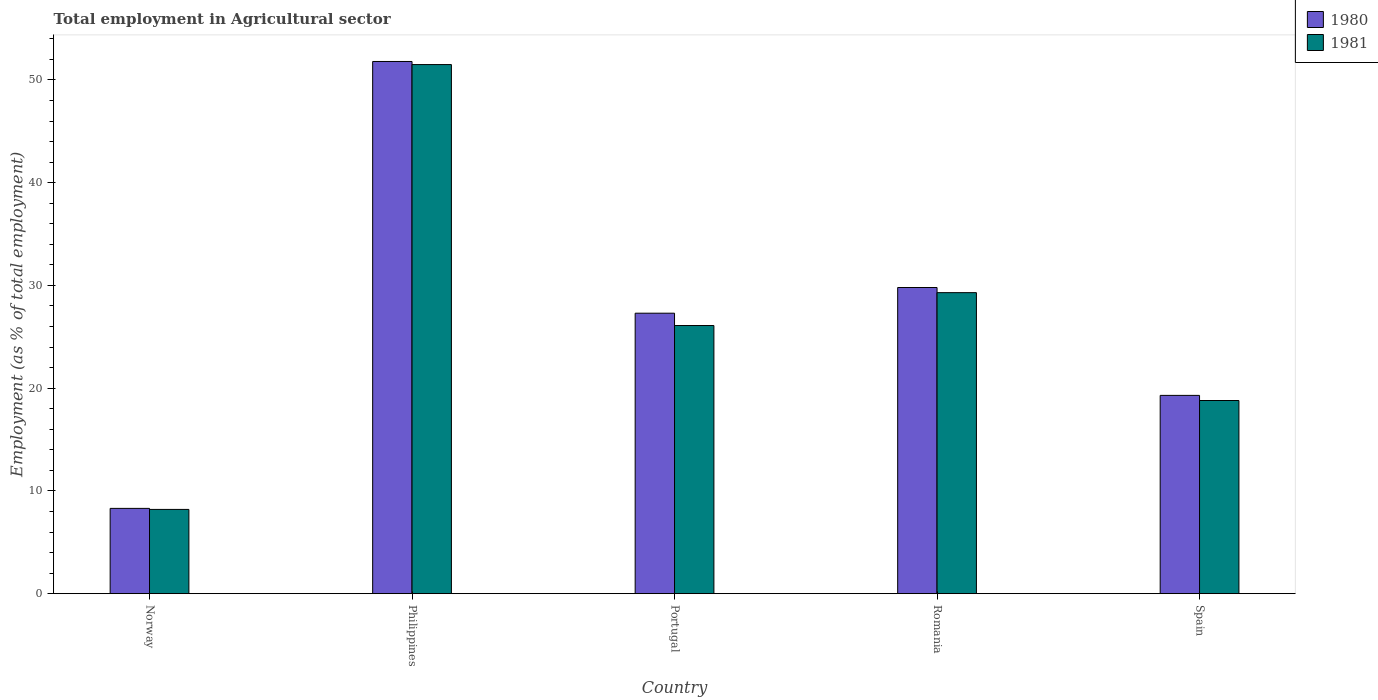How many groups of bars are there?
Provide a succinct answer. 5. Are the number of bars on each tick of the X-axis equal?
Your answer should be compact. Yes. How many bars are there on the 5th tick from the left?
Keep it short and to the point. 2. What is the label of the 5th group of bars from the left?
Offer a terse response. Spain. In how many cases, is the number of bars for a given country not equal to the number of legend labels?
Offer a terse response. 0. What is the employment in agricultural sector in 1981 in Philippines?
Ensure brevity in your answer.  51.5. Across all countries, what is the maximum employment in agricultural sector in 1981?
Give a very brief answer. 51.5. Across all countries, what is the minimum employment in agricultural sector in 1981?
Offer a terse response. 8.2. In which country was the employment in agricultural sector in 1981 maximum?
Offer a very short reply. Philippines. What is the total employment in agricultural sector in 1980 in the graph?
Offer a very short reply. 136.5. What is the difference between the employment in agricultural sector in 1981 in Portugal and that in Romania?
Provide a short and direct response. -3.2. What is the difference between the employment in agricultural sector in 1980 in Norway and the employment in agricultural sector in 1981 in Romania?
Make the answer very short. -21. What is the average employment in agricultural sector in 1981 per country?
Your response must be concise. 26.78. What is the difference between the employment in agricultural sector of/in 1981 and employment in agricultural sector of/in 1980 in Romania?
Your answer should be compact. -0.5. In how many countries, is the employment in agricultural sector in 1981 greater than 36 %?
Offer a terse response. 1. What is the ratio of the employment in agricultural sector in 1980 in Portugal to that in Spain?
Provide a succinct answer. 1.41. Is the employment in agricultural sector in 1981 in Philippines less than that in Romania?
Offer a very short reply. No. Is the difference between the employment in agricultural sector in 1981 in Portugal and Romania greater than the difference between the employment in agricultural sector in 1980 in Portugal and Romania?
Provide a short and direct response. No. What is the difference between the highest and the second highest employment in agricultural sector in 1980?
Offer a terse response. -24.5. What is the difference between the highest and the lowest employment in agricultural sector in 1981?
Offer a terse response. 43.3. In how many countries, is the employment in agricultural sector in 1980 greater than the average employment in agricultural sector in 1980 taken over all countries?
Keep it short and to the point. 2. How many bars are there?
Your answer should be compact. 10. Are all the bars in the graph horizontal?
Make the answer very short. No. Are the values on the major ticks of Y-axis written in scientific E-notation?
Your answer should be compact. No. Does the graph contain grids?
Make the answer very short. No. Where does the legend appear in the graph?
Offer a very short reply. Top right. How many legend labels are there?
Your answer should be very brief. 2. What is the title of the graph?
Give a very brief answer. Total employment in Agricultural sector. Does "1964" appear as one of the legend labels in the graph?
Keep it short and to the point. No. What is the label or title of the X-axis?
Offer a terse response. Country. What is the label or title of the Y-axis?
Provide a succinct answer. Employment (as % of total employment). What is the Employment (as % of total employment) of 1980 in Norway?
Offer a terse response. 8.3. What is the Employment (as % of total employment) of 1981 in Norway?
Provide a short and direct response. 8.2. What is the Employment (as % of total employment) of 1980 in Philippines?
Offer a terse response. 51.8. What is the Employment (as % of total employment) of 1981 in Philippines?
Your answer should be compact. 51.5. What is the Employment (as % of total employment) of 1980 in Portugal?
Provide a succinct answer. 27.3. What is the Employment (as % of total employment) in 1981 in Portugal?
Provide a succinct answer. 26.1. What is the Employment (as % of total employment) in 1980 in Romania?
Ensure brevity in your answer.  29.8. What is the Employment (as % of total employment) of 1981 in Romania?
Provide a succinct answer. 29.3. What is the Employment (as % of total employment) of 1980 in Spain?
Provide a short and direct response. 19.3. What is the Employment (as % of total employment) in 1981 in Spain?
Offer a terse response. 18.8. Across all countries, what is the maximum Employment (as % of total employment) of 1980?
Ensure brevity in your answer.  51.8. Across all countries, what is the maximum Employment (as % of total employment) in 1981?
Your answer should be very brief. 51.5. Across all countries, what is the minimum Employment (as % of total employment) in 1980?
Provide a short and direct response. 8.3. Across all countries, what is the minimum Employment (as % of total employment) of 1981?
Offer a terse response. 8.2. What is the total Employment (as % of total employment) in 1980 in the graph?
Your answer should be compact. 136.5. What is the total Employment (as % of total employment) of 1981 in the graph?
Ensure brevity in your answer.  133.9. What is the difference between the Employment (as % of total employment) in 1980 in Norway and that in Philippines?
Offer a very short reply. -43.5. What is the difference between the Employment (as % of total employment) in 1981 in Norway and that in Philippines?
Ensure brevity in your answer.  -43.3. What is the difference between the Employment (as % of total employment) of 1980 in Norway and that in Portugal?
Your answer should be compact. -19. What is the difference between the Employment (as % of total employment) in 1981 in Norway and that in Portugal?
Provide a succinct answer. -17.9. What is the difference between the Employment (as % of total employment) in 1980 in Norway and that in Romania?
Offer a very short reply. -21.5. What is the difference between the Employment (as % of total employment) in 1981 in Norway and that in Romania?
Offer a very short reply. -21.1. What is the difference between the Employment (as % of total employment) of 1980 in Norway and that in Spain?
Offer a very short reply. -11. What is the difference between the Employment (as % of total employment) of 1981 in Philippines and that in Portugal?
Your answer should be very brief. 25.4. What is the difference between the Employment (as % of total employment) of 1980 in Philippines and that in Spain?
Give a very brief answer. 32.5. What is the difference between the Employment (as % of total employment) in 1981 in Philippines and that in Spain?
Your answer should be compact. 32.7. What is the difference between the Employment (as % of total employment) of 1980 in Romania and that in Spain?
Provide a short and direct response. 10.5. What is the difference between the Employment (as % of total employment) in 1981 in Romania and that in Spain?
Ensure brevity in your answer.  10.5. What is the difference between the Employment (as % of total employment) in 1980 in Norway and the Employment (as % of total employment) in 1981 in Philippines?
Offer a terse response. -43.2. What is the difference between the Employment (as % of total employment) in 1980 in Norway and the Employment (as % of total employment) in 1981 in Portugal?
Offer a very short reply. -17.8. What is the difference between the Employment (as % of total employment) of 1980 in Norway and the Employment (as % of total employment) of 1981 in Romania?
Your answer should be compact. -21. What is the difference between the Employment (as % of total employment) in 1980 in Norway and the Employment (as % of total employment) in 1981 in Spain?
Make the answer very short. -10.5. What is the difference between the Employment (as % of total employment) of 1980 in Philippines and the Employment (as % of total employment) of 1981 in Portugal?
Your response must be concise. 25.7. What is the difference between the Employment (as % of total employment) of 1980 in Philippines and the Employment (as % of total employment) of 1981 in Romania?
Offer a terse response. 22.5. What is the difference between the Employment (as % of total employment) of 1980 in Philippines and the Employment (as % of total employment) of 1981 in Spain?
Give a very brief answer. 33. What is the difference between the Employment (as % of total employment) of 1980 in Romania and the Employment (as % of total employment) of 1981 in Spain?
Give a very brief answer. 11. What is the average Employment (as % of total employment) in 1980 per country?
Your answer should be very brief. 27.3. What is the average Employment (as % of total employment) of 1981 per country?
Make the answer very short. 26.78. What is the ratio of the Employment (as % of total employment) in 1980 in Norway to that in Philippines?
Your answer should be compact. 0.16. What is the ratio of the Employment (as % of total employment) in 1981 in Norway to that in Philippines?
Offer a terse response. 0.16. What is the ratio of the Employment (as % of total employment) in 1980 in Norway to that in Portugal?
Provide a short and direct response. 0.3. What is the ratio of the Employment (as % of total employment) of 1981 in Norway to that in Portugal?
Your response must be concise. 0.31. What is the ratio of the Employment (as % of total employment) of 1980 in Norway to that in Romania?
Give a very brief answer. 0.28. What is the ratio of the Employment (as % of total employment) in 1981 in Norway to that in Romania?
Your response must be concise. 0.28. What is the ratio of the Employment (as % of total employment) in 1980 in Norway to that in Spain?
Provide a succinct answer. 0.43. What is the ratio of the Employment (as % of total employment) of 1981 in Norway to that in Spain?
Your response must be concise. 0.44. What is the ratio of the Employment (as % of total employment) in 1980 in Philippines to that in Portugal?
Make the answer very short. 1.9. What is the ratio of the Employment (as % of total employment) of 1981 in Philippines to that in Portugal?
Your answer should be compact. 1.97. What is the ratio of the Employment (as % of total employment) in 1980 in Philippines to that in Romania?
Your answer should be compact. 1.74. What is the ratio of the Employment (as % of total employment) in 1981 in Philippines to that in Romania?
Give a very brief answer. 1.76. What is the ratio of the Employment (as % of total employment) of 1980 in Philippines to that in Spain?
Provide a succinct answer. 2.68. What is the ratio of the Employment (as % of total employment) in 1981 in Philippines to that in Spain?
Your answer should be compact. 2.74. What is the ratio of the Employment (as % of total employment) of 1980 in Portugal to that in Romania?
Your answer should be compact. 0.92. What is the ratio of the Employment (as % of total employment) of 1981 in Portugal to that in Romania?
Give a very brief answer. 0.89. What is the ratio of the Employment (as % of total employment) in 1980 in Portugal to that in Spain?
Keep it short and to the point. 1.41. What is the ratio of the Employment (as % of total employment) in 1981 in Portugal to that in Spain?
Offer a very short reply. 1.39. What is the ratio of the Employment (as % of total employment) in 1980 in Romania to that in Spain?
Ensure brevity in your answer.  1.54. What is the ratio of the Employment (as % of total employment) of 1981 in Romania to that in Spain?
Your answer should be very brief. 1.56. What is the difference between the highest and the lowest Employment (as % of total employment) of 1980?
Your answer should be very brief. 43.5. What is the difference between the highest and the lowest Employment (as % of total employment) of 1981?
Your response must be concise. 43.3. 